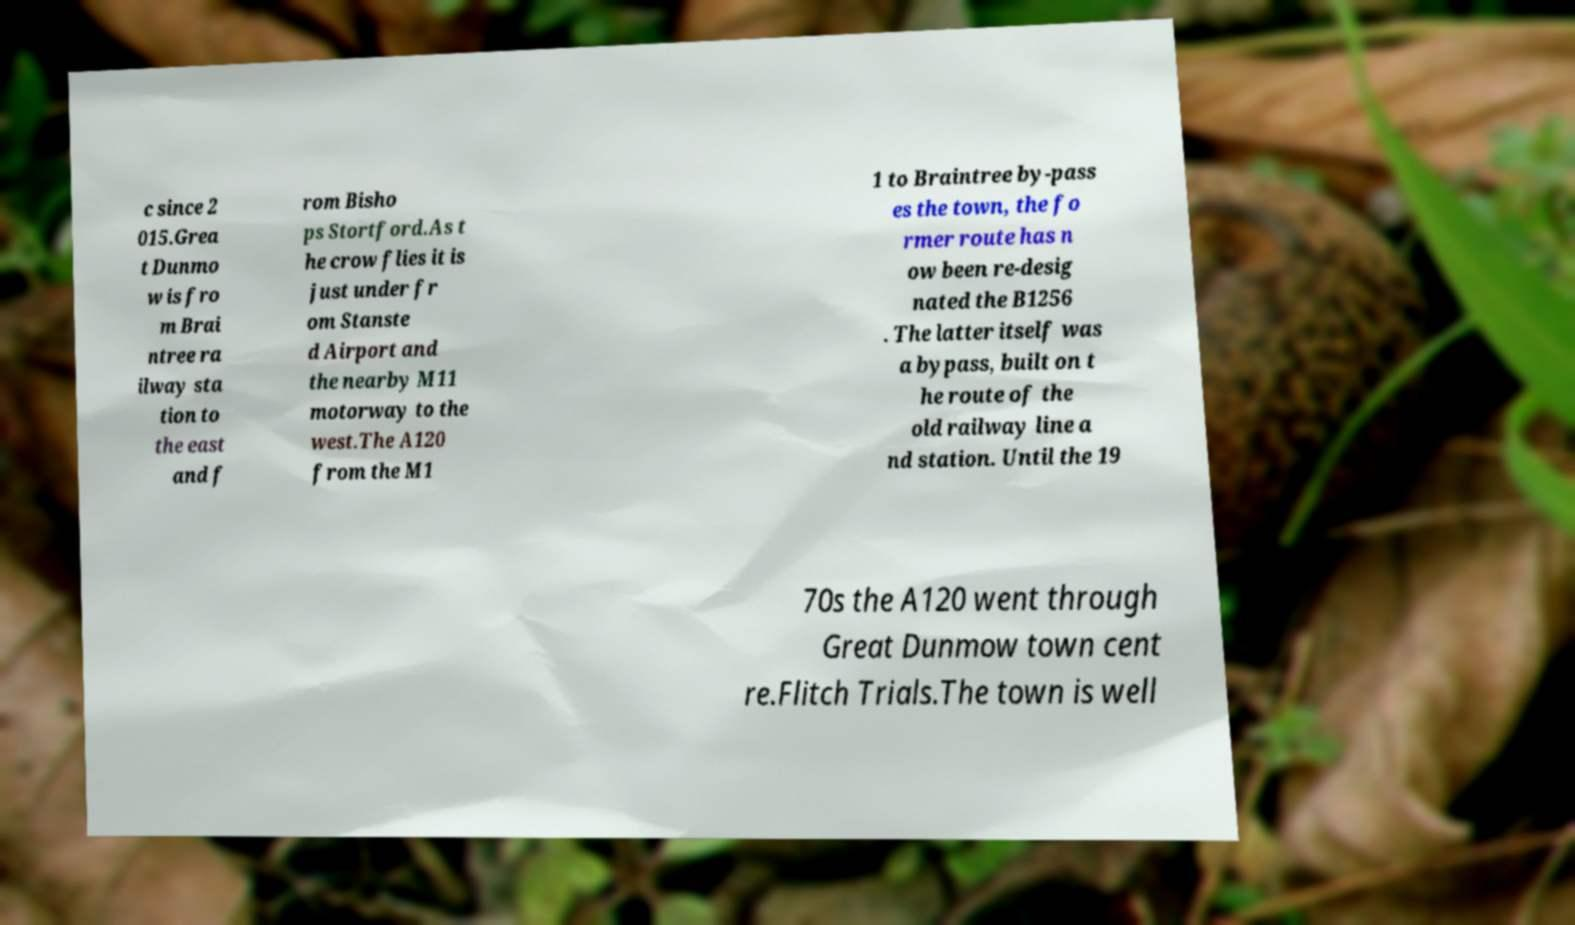I need the written content from this picture converted into text. Can you do that? c since 2 015.Grea t Dunmo w is fro m Brai ntree ra ilway sta tion to the east and f rom Bisho ps Stortford.As t he crow flies it is just under fr om Stanste d Airport and the nearby M11 motorway to the west.The A120 from the M1 1 to Braintree by-pass es the town, the fo rmer route has n ow been re-desig nated the B1256 . The latter itself was a bypass, built on t he route of the old railway line a nd station. Until the 19 70s the A120 went through Great Dunmow town cent re.Flitch Trials.The town is well 